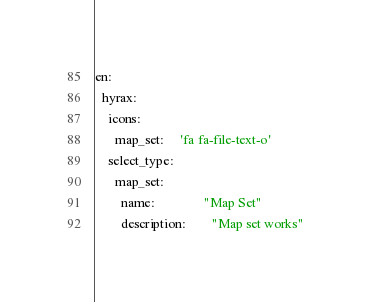<code> <loc_0><loc_0><loc_500><loc_500><_YAML_>en:
  hyrax:
    icons:
      map_set:     'fa fa-file-text-o'
    select_type:
      map_set:
        name:               "Map Set"
        description:        "Map set works"
</code> 